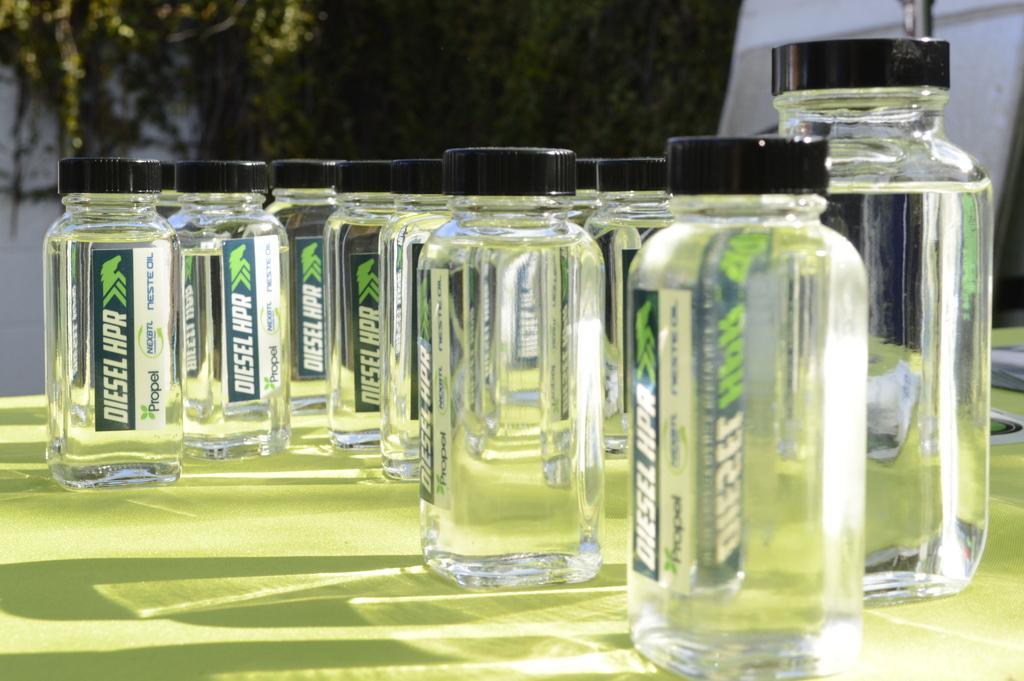Could you give a brief overview of what you see in this image? In this picture we can see glass bottles with caps to it are placed on a table and in background we can see trees, wall. 